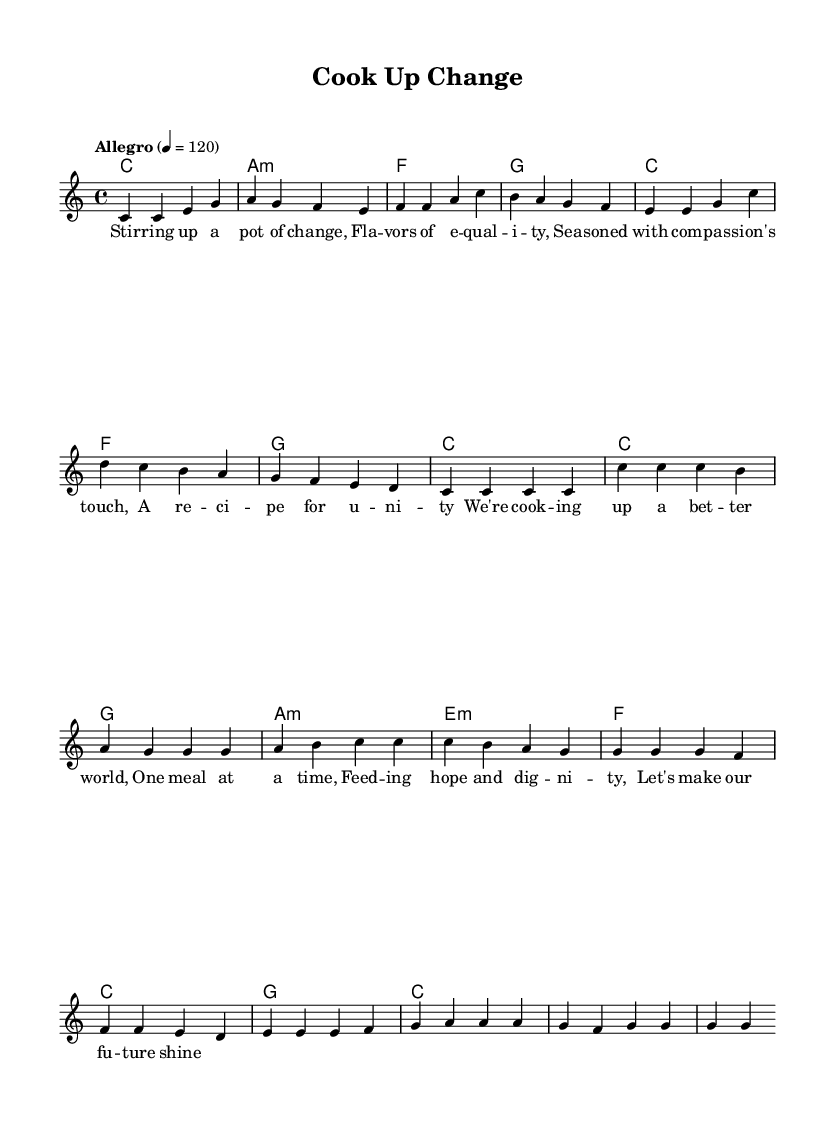What is the key signature of this music? The key signature is C major, which has no sharps or flats.
Answer: C major What is the time signature of the piece? The time signature is found at the beginning of the sheet music. It shows that there are four beats in each measure, indicated by 4/4.
Answer: 4/4 What is the tempo marking for this piece? The tempo marking indicates how fast the piece should be played. It is marked "Allegro" with a metronome marking of 120 beats per minute.
Answer: Allegro How many measures are in the verse? Counting the measures specifically in the verse section, there are eight measures.
Answer: 8 What is the first lyric of the chorus? By looking at the lyrics under the music notation, the first lyric of the chorus is "We're."
Answer: We're Which chord is played at the beginning of the phrase? The first chord of the piece is indicated in the chord section. It shows a C major chord at the start of the verse.
Answer: C What is the relationship between the last chord of the melody and the first chord of the next phrase? The last chord of the melody of the verse is C major, which leads into the first chord of the chorus, also C major. This indicates a smooth transition between the two sections.
Answer: C major 